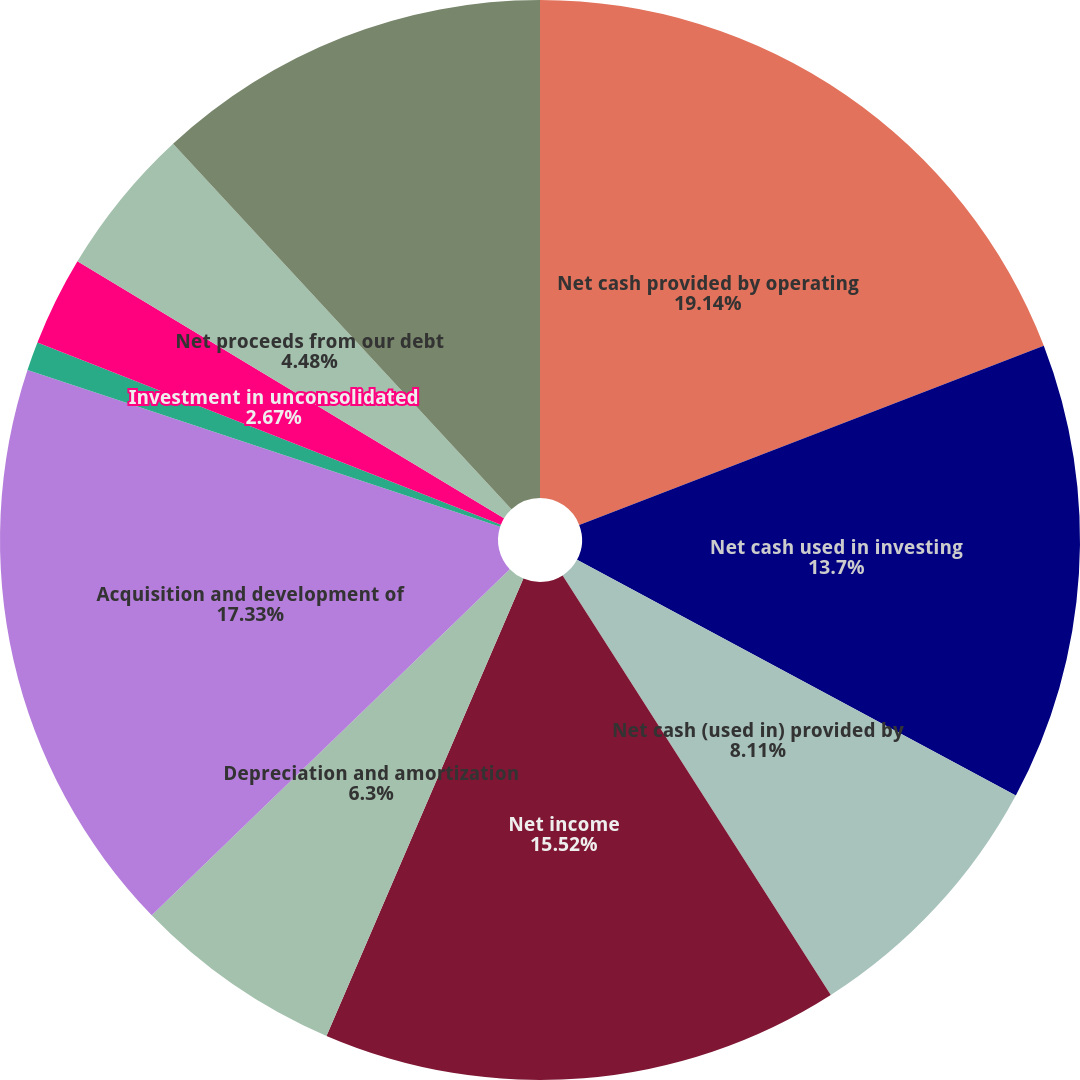<chart> <loc_0><loc_0><loc_500><loc_500><pie_chart><fcel>Net cash provided by operating<fcel>Net cash used in investing<fcel>Net cash (used in) provided by<fcel>Net income<fcel>Depreciation and amortization<fcel>Acquisition and development of<fcel>Gain on real estate<fcel>Investment in unconsolidated<fcel>Net proceeds from our debt<fcel>Dividends paid on common stock<nl><fcel>19.14%<fcel>13.7%<fcel>8.11%<fcel>15.52%<fcel>6.3%<fcel>17.33%<fcel>0.86%<fcel>2.67%<fcel>4.48%<fcel>11.89%<nl></chart> 